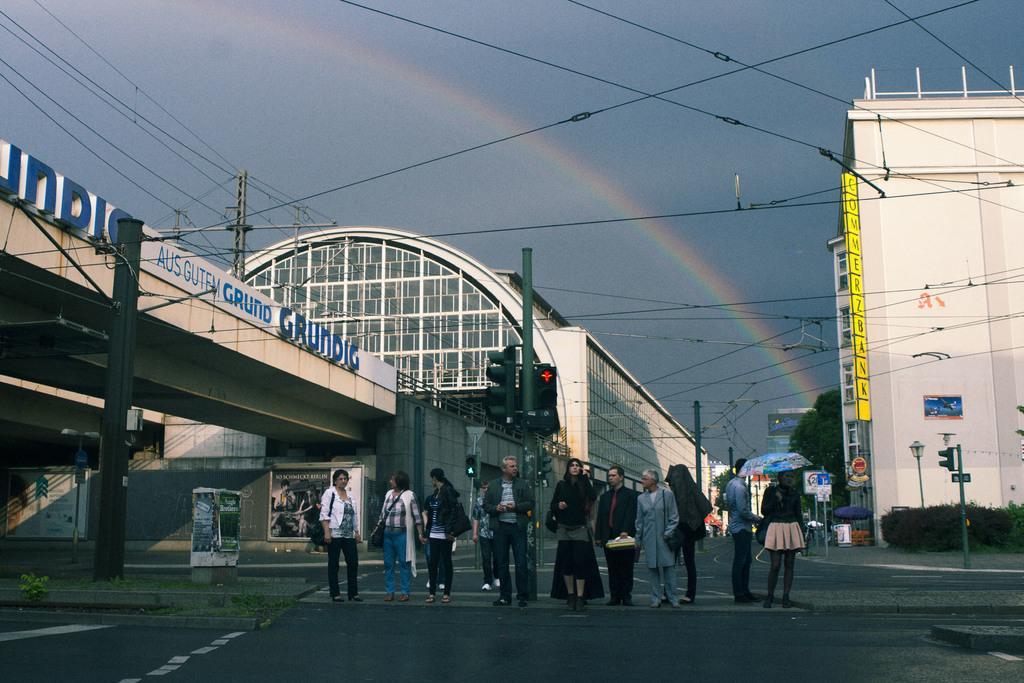Could you give a brief overview of what you see in this image? In this image, we can see people standing on the road and in the background, there is a bridge, buildings, trees, poles along with wires, traffic lights, sign boards and there are bushes. 